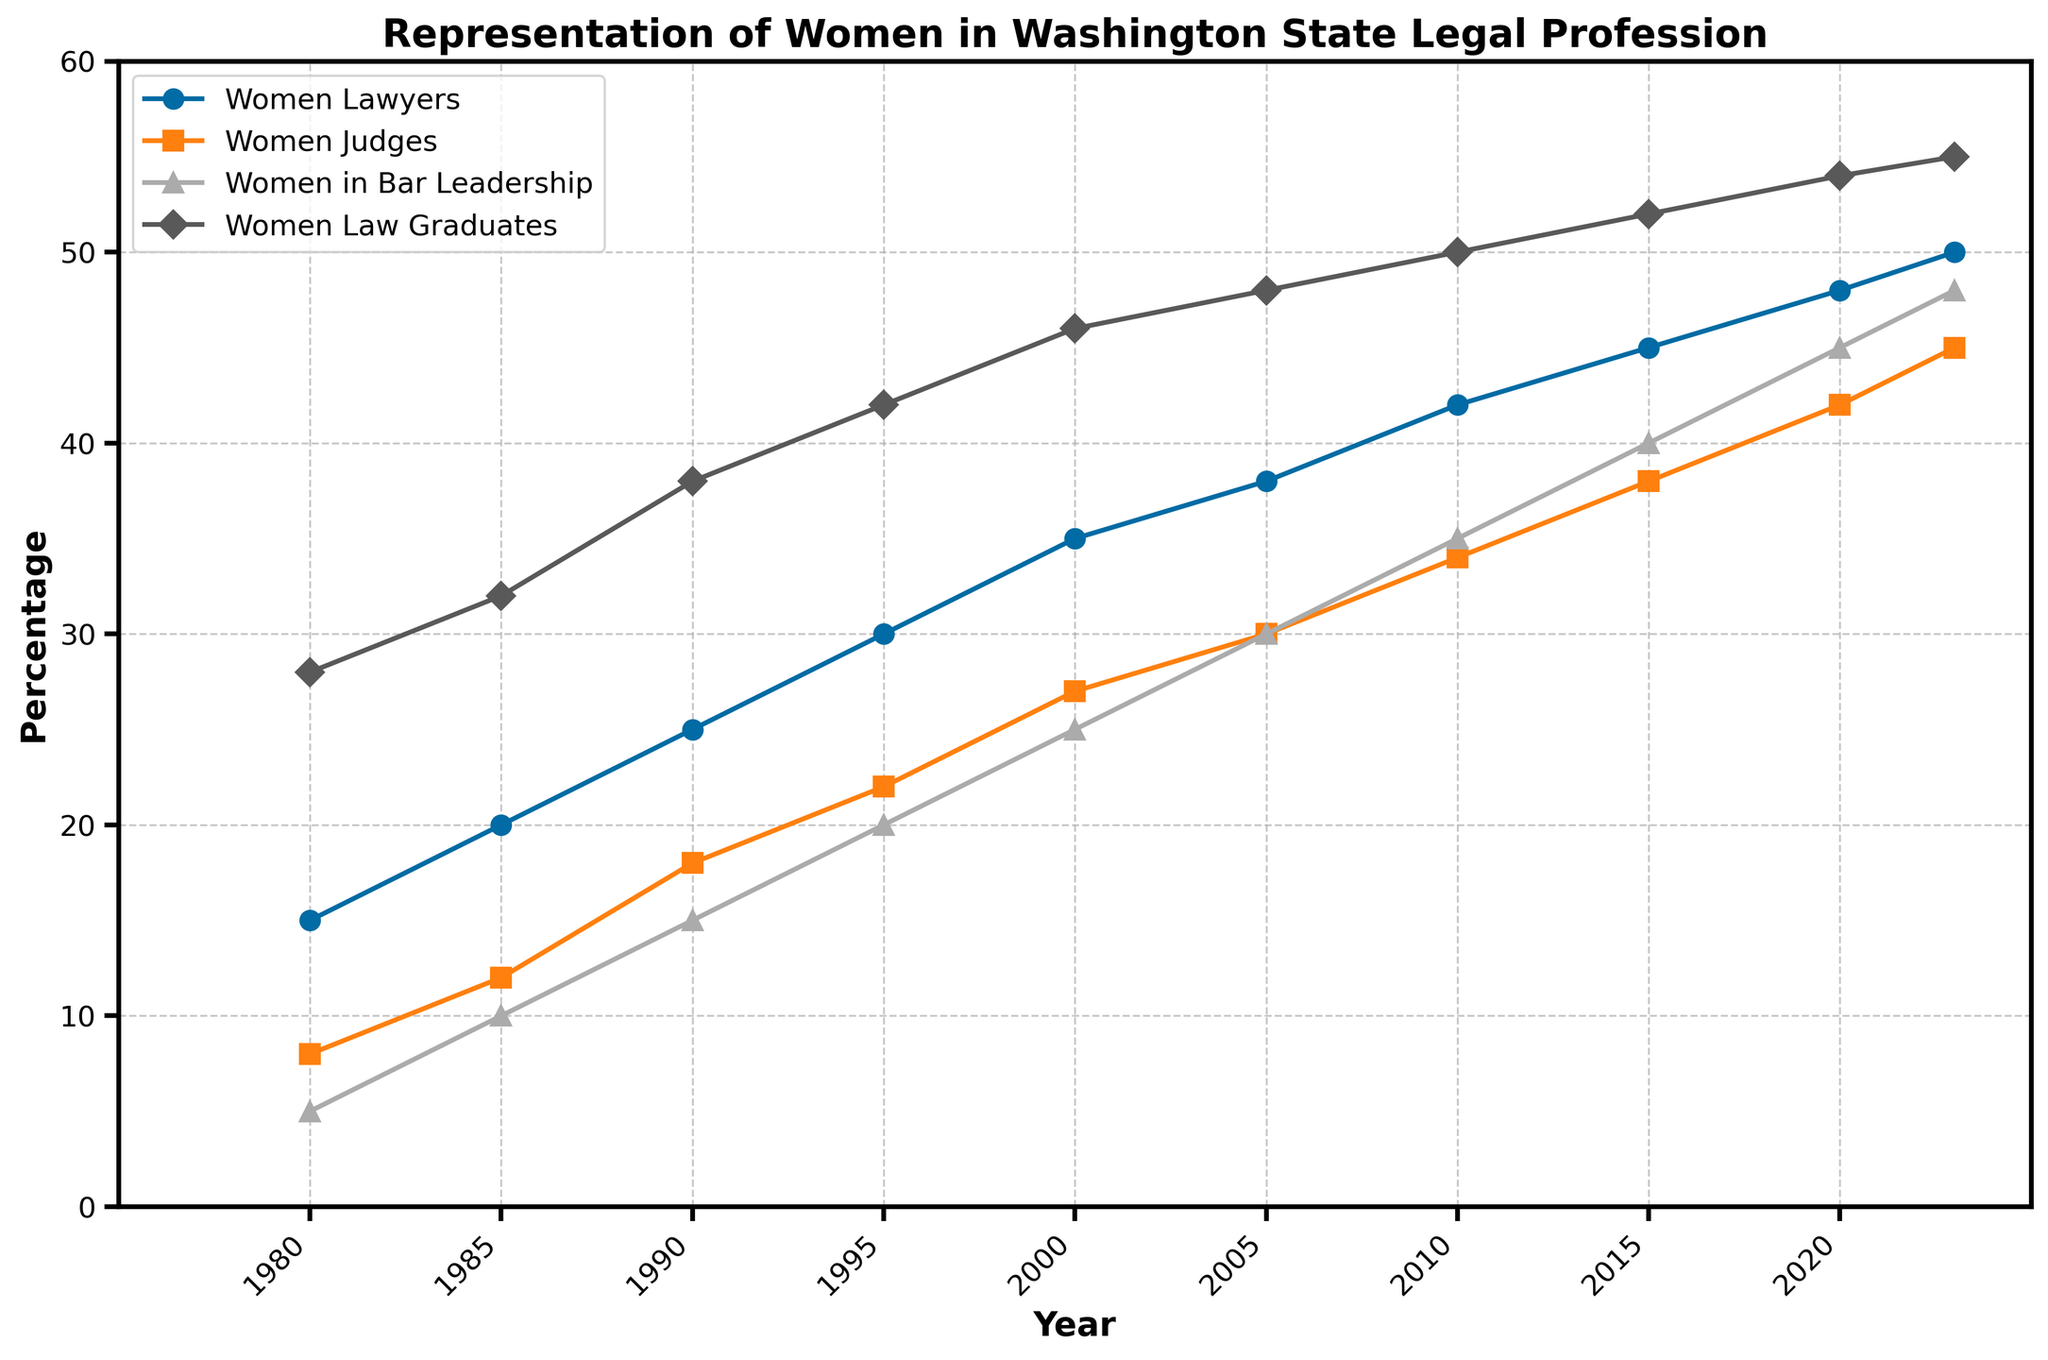How has the percentage of women law school graduates changed from 1980 to 2023? The percentage of women law school graduates in 1980 was 28%, and in 2023 it is 55%. The change is 55% - 28% = 27%.
Answer: 27% Which group has seen the greatest increase in representation from 1980 to 2023? By calculating the increase for each group: Women Lawyers (50% - 15% = 35%), Women Judges (45% - 8% = 37%), Women in Bar Leadership (48% - 5% = 43%), Women Law Graduates (55% - 28% = 27%), we see that Women in Bar Leadership has the greatest increase (43%).
Answer: Women in Bar Leadership What general trend can you observe in the representation of women in the legal profession over the years? All four categories show an increasing trend. The percentage of women in each category consistently rises from 1980 to 2023.
Answer: Increasing In which year did the representation of women lawyers first reach 30%? By inspecting the figure, we see that the line representing women lawyers crosses 30% around 2005.
Answer: 2005 Compare the percentage of women judges in 2000 to women in Bar leadership in the same year. Which is higher? Looking at 2000, women judges are at 27% while women in Bar leadership are at 25%.
Answer: Women Judges What is the average percentage of women law school graduates between 1980 and 2023? The percentages are 28, 32, 38, 42, 46, 48, 50, 52, 54, and 55. The sum is 28 + 32 + 38 + 42 + 46 + 48 + 50 + 52 + 54 + 55 = 445. Dividing by 10 (number of years) gives the average as 445/10 = 44.5%.
Answer: 44.5% Which group saw the smallest percentage representation in 1980? In 1980, the percentages are: Women Lawyers (15%), Women Judges (8%), Women in Bar leadership (5%), Women Law Graduates (28%). The smallest percentage is for Women in Bar leadership at 5%.
Answer: Women in Bar Leadership What’s the difference in the percentage of women lawyers and women in Bar leadership in 2023? In 2023, women lawyers are at 50% and women in Bar leadership are at 48%. The difference is 50% - 48% = 2%.
Answer: 2% Between 1990 and 2000, which group experienced the greatest increase in percentage? Women Lawyers: 35-25=10%, Women Judges: 27-18=9%, Women in Bar leadership: 25-15=10%, Women Law Graduates: 46-38=8%. The greatest increase was for Women Lawyers and Women in Bar Leadership (10%).
Answer: Women Lawyers and Women in Bar Leadership 